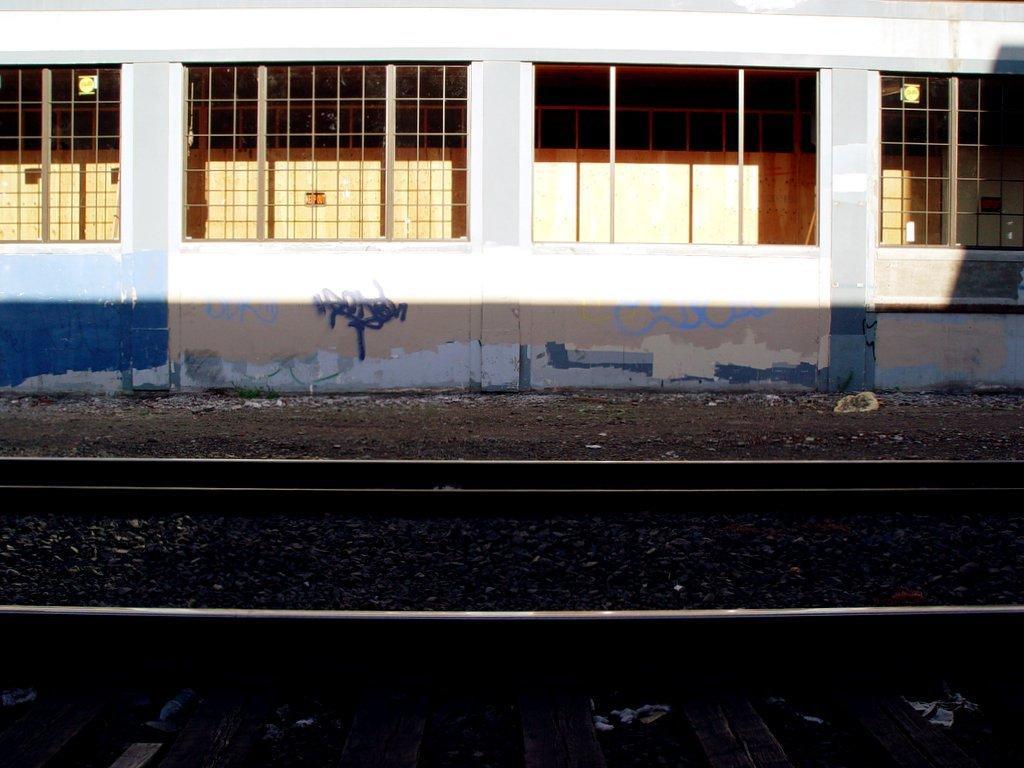In one or two sentences, can you explain what this image depicts? This picture is clicked outside. In the foreground we can see the gravels and the railway track. In the background we can see the windows and the wall of a building. 